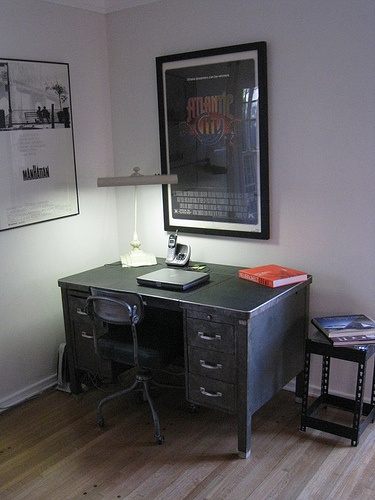Describe the objects in this image and their specific colors. I can see chair in gray and black tones, book in gray, brown, red, and darkgray tones, book in gray, darkgray, and navy tones, laptop in gray, darkgray, black, and lightgray tones, and cell phone in gray, lightgray, darkgray, and black tones in this image. 